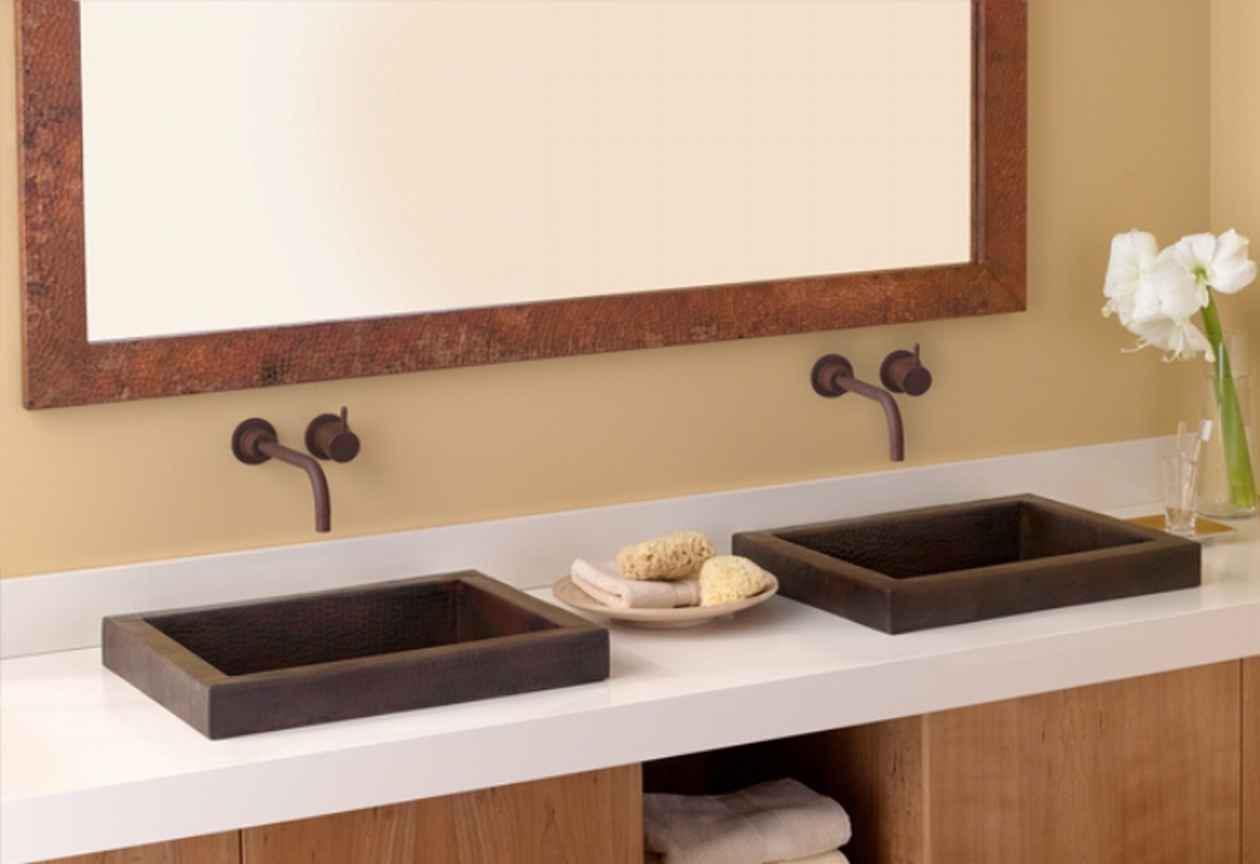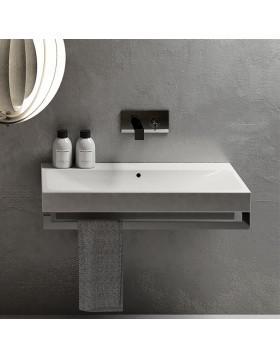The first image is the image on the left, the second image is the image on the right. Evaluate the accuracy of this statement regarding the images: "One sink is round and the other is rectangular; also, one sink is inset, and the other is elevated above the counter.". Is it true? Answer yes or no. No. The first image is the image on the left, the second image is the image on the right. For the images displayed, is the sentence "One of images shows folded towels stored beneath the sink." factually correct? Answer yes or no. Yes. 